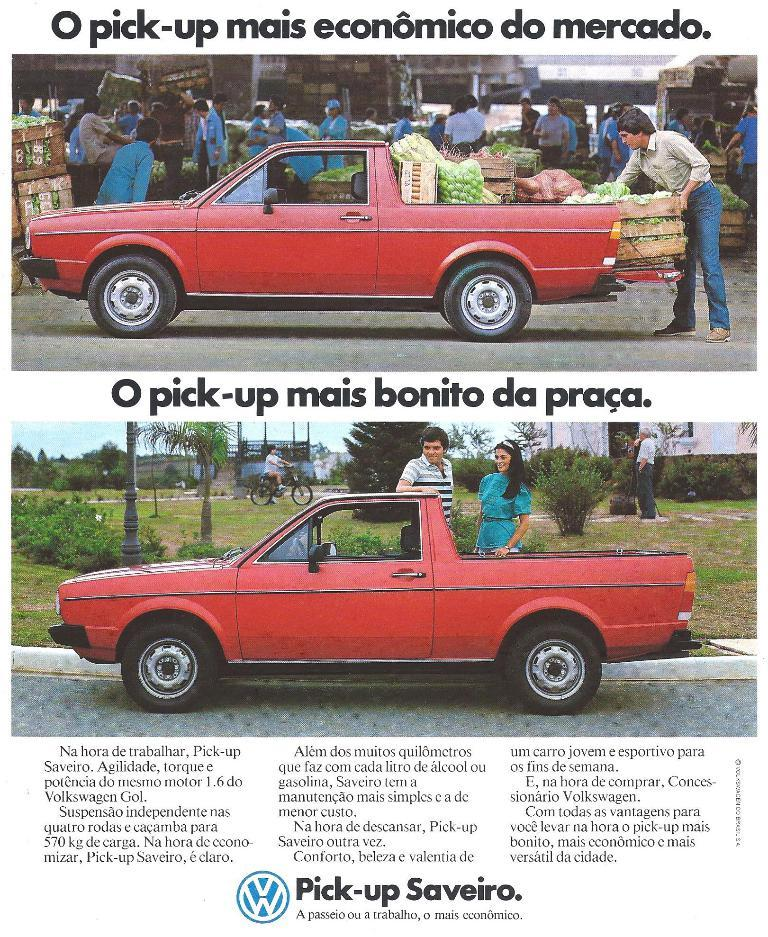What is featured on the poster in the image? There is a poster in the image that contains two images of a red color car. What else can be seen on the poster besides the images of the car? There is text on the poster. What type of government is depicted in the image? There is no depiction of a government in the image; it features a poster with images of a red car and text. What kind of stone can be seen in the image? There is no stone present in the image. 